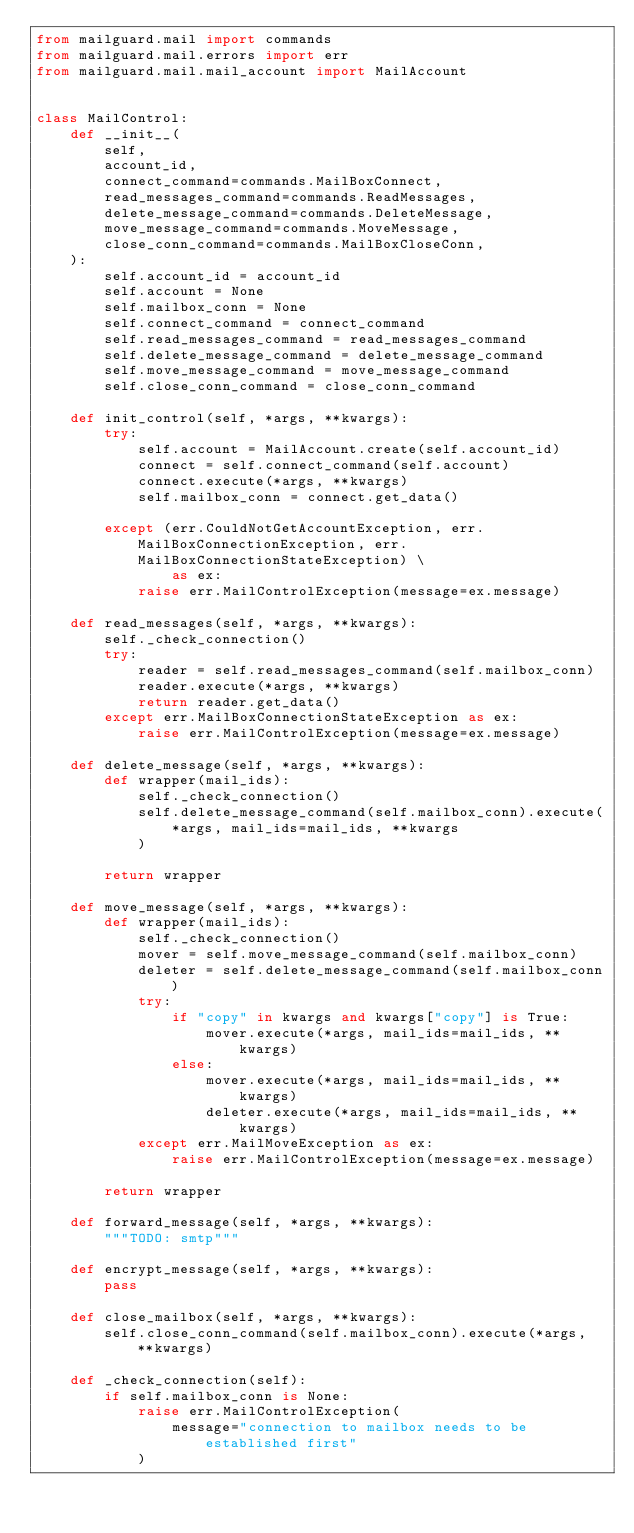Convert code to text. <code><loc_0><loc_0><loc_500><loc_500><_Python_>from mailguard.mail import commands
from mailguard.mail.errors import err
from mailguard.mail.mail_account import MailAccount


class MailControl:
    def __init__(
        self,
        account_id,
        connect_command=commands.MailBoxConnect,
        read_messages_command=commands.ReadMessages,
        delete_message_command=commands.DeleteMessage,
        move_message_command=commands.MoveMessage,
        close_conn_command=commands.MailBoxCloseConn,
    ):
        self.account_id = account_id
        self.account = None
        self.mailbox_conn = None
        self.connect_command = connect_command
        self.read_messages_command = read_messages_command
        self.delete_message_command = delete_message_command
        self.move_message_command = move_message_command
        self.close_conn_command = close_conn_command

    def init_control(self, *args, **kwargs):
        try:
            self.account = MailAccount.create(self.account_id)
            connect = self.connect_command(self.account)
            connect.execute(*args, **kwargs)
            self.mailbox_conn = connect.get_data()

        except (err.CouldNotGetAccountException, err.MailBoxConnectionException, err.MailBoxConnectionStateException) \
                as ex:
            raise err.MailControlException(message=ex.message)

    def read_messages(self, *args, **kwargs):
        self._check_connection()
        try:
            reader = self.read_messages_command(self.mailbox_conn)
            reader.execute(*args, **kwargs)
            return reader.get_data()
        except err.MailBoxConnectionStateException as ex:
            raise err.MailControlException(message=ex.message)

    def delete_message(self, *args, **kwargs):
        def wrapper(mail_ids):
            self._check_connection()
            self.delete_message_command(self.mailbox_conn).execute(
                *args, mail_ids=mail_ids, **kwargs
            )

        return wrapper

    def move_message(self, *args, **kwargs):
        def wrapper(mail_ids):
            self._check_connection()
            mover = self.move_message_command(self.mailbox_conn)
            deleter = self.delete_message_command(self.mailbox_conn)
            try:
                if "copy" in kwargs and kwargs["copy"] is True:
                    mover.execute(*args, mail_ids=mail_ids, **kwargs)
                else:
                    mover.execute(*args, mail_ids=mail_ids, **kwargs)
                    deleter.execute(*args, mail_ids=mail_ids, **kwargs)
            except err.MailMoveException as ex:
                raise err.MailControlException(message=ex.message)

        return wrapper

    def forward_message(self, *args, **kwargs):
        """TODO: smtp"""

    def encrypt_message(self, *args, **kwargs):
        pass

    def close_mailbox(self, *args, **kwargs):
        self.close_conn_command(self.mailbox_conn).execute(*args, **kwargs)

    def _check_connection(self):
        if self.mailbox_conn is None:
            raise err.MailControlException(
                message="connection to mailbox needs to be established first"
            )
</code> 